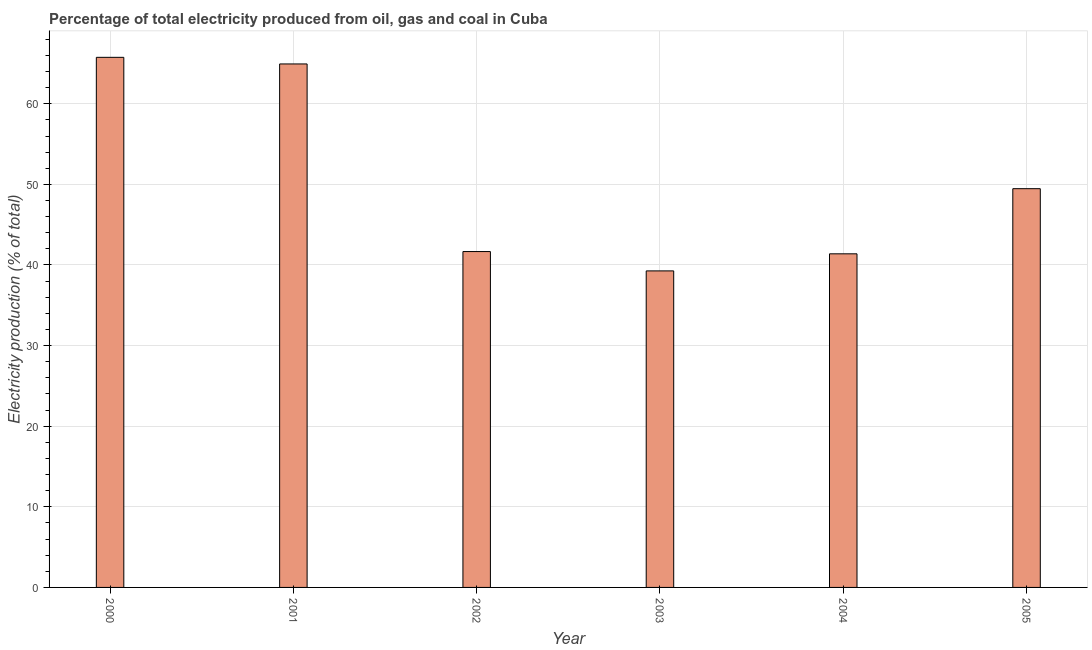Does the graph contain any zero values?
Keep it short and to the point. No. What is the title of the graph?
Keep it short and to the point. Percentage of total electricity produced from oil, gas and coal in Cuba. What is the label or title of the X-axis?
Make the answer very short. Year. What is the label or title of the Y-axis?
Offer a terse response. Electricity production (% of total). What is the electricity production in 2003?
Provide a short and direct response. 39.27. Across all years, what is the maximum electricity production?
Offer a terse response. 65.76. Across all years, what is the minimum electricity production?
Make the answer very short. 39.27. In which year was the electricity production maximum?
Your answer should be compact. 2000. What is the sum of the electricity production?
Provide a short and direct response. 302.48. What is the difference between the electricity production in 2000 and 2001?
Ensure brevity in your answer.  0.82. What is the average electricity production per year?
Provide a short and direct response. 50.41. What is the median electricity production?
Offer a very short reply. 45.57. Do a majority of the years between 2002 and 2003 (inclusive) have electricity production greater than 52 %?
Ensure brevity in your answer.  No. What is the ratio of the electricity production in 2002 to that in 2003?
Keep it short and to the point. 1.06. Is the difference between the electricity production in 2000 and 2004 greater than the difference between any two years?
Make the answer very short. No. What is the difference between the highest and the second highest electricity production?
Ensure brevity in your answer.  0.82. What is the difference between the highest and the lowest electricity production?
Give a very brief answer. 26.49. How many bars are there?
Your answer should be compact. 6. What is the difference between two consecutive major ticks on the Y-axis?
Offer a very short reply. 10. Are the values on the major ticks of Y-axis written in scientific E-notation?
Make the answer very short. No. What is the Electricity production (% of total) of 2000?
Provide a succinct answer. 65.76. What is the Electricity production (% of total) of 2001?
Ensure brevity in your answer.  64.94. What is the Electricity production (% of total) in 2002?
Keep it short and to the point. 41.67. What is the Electricity production (% of total) of 2003?
Ensure brevity in your answer.  39.27. What is the Electricity production (% of total) in 2004?
Ensure brevity in your answer.  41.38. What is the Electricity production (% of total) in 2005?
Offer a very short reply. 49.47. What is the difference between the Electricity production (% of total) in 2000 and 2001?
Provide a succinct answer. 0.82. What is the difference between the Electricity production (% of total) in 2000 and 2002?
Give a very brief answer. 24.09. What is the difference between the Electricity production (% of total) in 2000 and 2003?
Your answer should be very brief. 26.49. What is the difference between the Electricity production (% of total) in 2000 and 2004?
Provide a succinct answer. 24.38. What is the difference between the Electricity production (% of total) in 2000 and 2005?
Your response must be concise. 16.29. What is the difference between the Electricity production (% of total) in 2001 and 2002?
Offer a very short reply. 23.27. What is the difference between the Electricity production (% of total) in 2001 and 2003?
Your response must be concise. 25.67. What is the difference between the Electricity production (% of total) in 2001 and 2004?
Give a very brief answer. 23.55. What is the difference between the Electricity production (% of total) in 2001 and 2005?
Your answer should be very brief. 15.47. What is the difference between the Electricity production (% of total) in 2002 and 2003?
Keep it short and to the point. 2.4. What is the difference between the Electricity production (% of total) in 2002 and 2004?
Offer a terse response. 0.28. What is the difference between the Electricity production (% of total) in 2002 and 2005?
Offer a very short reply. -7.8. What is the difference between the Electricity production (% of total) in 2003 and 2004?
Offer a very short reply. -2.12. What is the difference between the Electricity production (% of total) in 2003 and 2005?
Your response must be concise. -10.2. What is the difference between the Electricity production (% of total) in 2004 and 2005?
Your answer should be compact. -8.08. What is the ratio of the Electricity production (% of total) in 2000 to that in 2001?
Your response must be concise. 1.01. What is the ratio of the Electricity production (% of total) in 2000 to that in 2002?
Give a very brief answer. 1.58. What is the ratio of the Electricity production (% of total) in 2000 to that in 2003?
Ensure brevity in your answer.  1.68. What is the ratio of the Electricity production (% of total) in 2000 to that in 2004?
Provide a succinct answer. 1.59. What is the ratio of the Electricity production (% of total) in 2000 to that in 2005?
Offer a very short reply. 1.33. What is the ratio of the Electricity production (% of total) in 2001 to that in 2002?
Give a very brief answer. 1.56. What is the ratio of the Electricity production (% of total) in 2001 to that in 2003?
Offer a terse response. 1.65. What is the ratio of the Electricity production (% of total) in 2001 to that in 2004?
Ensure brevity in your answer.  1.57. What is the ratio of the Electricity production (% of total) in 2001 to that in 2005?
Make the answer very short. 1.31. What is the ratio of the Electricity production (% of total) in 2002 to that in 2003?
Your response must be concise. 1.06. What is the ratio of the Electricity production (% of total) in 2002 to that in 2005?
Ensure brevity in your answer.  0.84. What is the ratio of the Electricity production (% of total) in 2003 to that in 2004?
Offer a terse response. 0.95. What is the ratio of the Electricity production (% of total) in 2003 to that in 2005?
Keep it short and to the point. 0.79. What is the ratio of the Electricity production (% of total) in 2004 to that in 2005?
Offer a terse response. 0.84. 